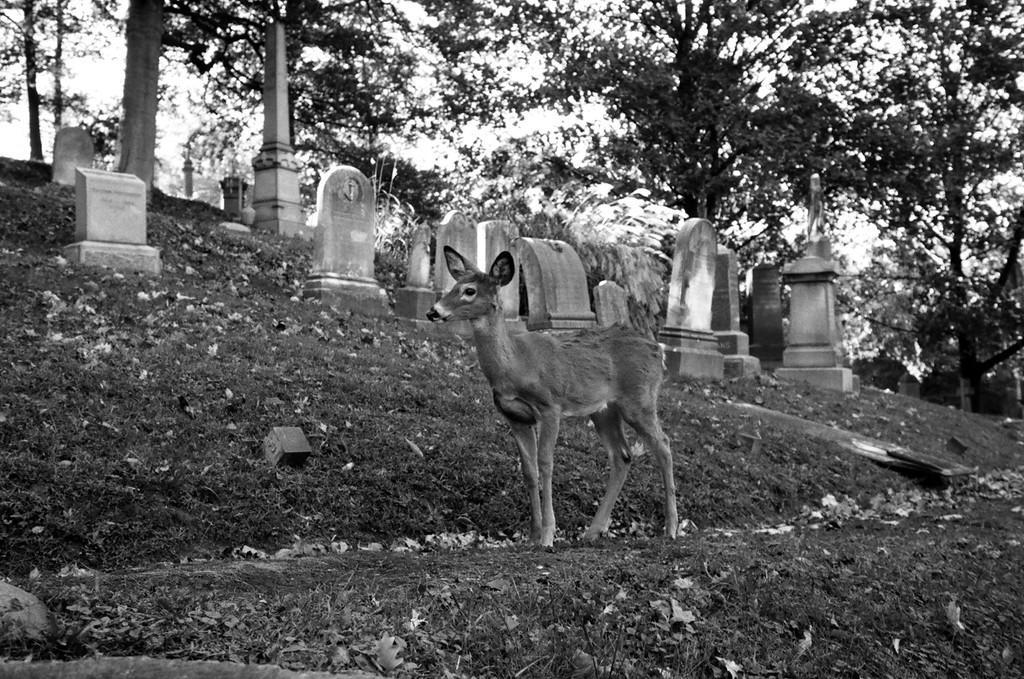Could you give a brief overview of what you see in this image? In this picture I can see there is a deer standing here and there is grass and dry leaves on the floor and there are grave stones in the backdrop and the sky is clear. This is a black and white picture. 